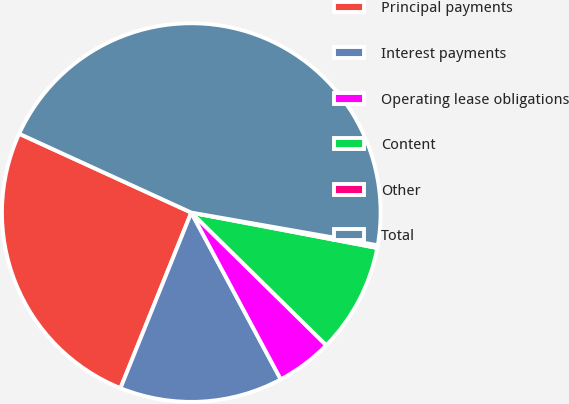<chart> <loc_0><loc_0><loc_500><loc_500><pie_chart><fcel>Principal payments<fcel>Interest payments<fcel>Operating lease obligations<fcel>Content<fcel>Other<fcel>Total<nl><fcel>25.74%<fcel>13.94%<fcel>4.8%<fcel>9.37%<fcel>0.23%<fcel>45.93%<nl></chart> 